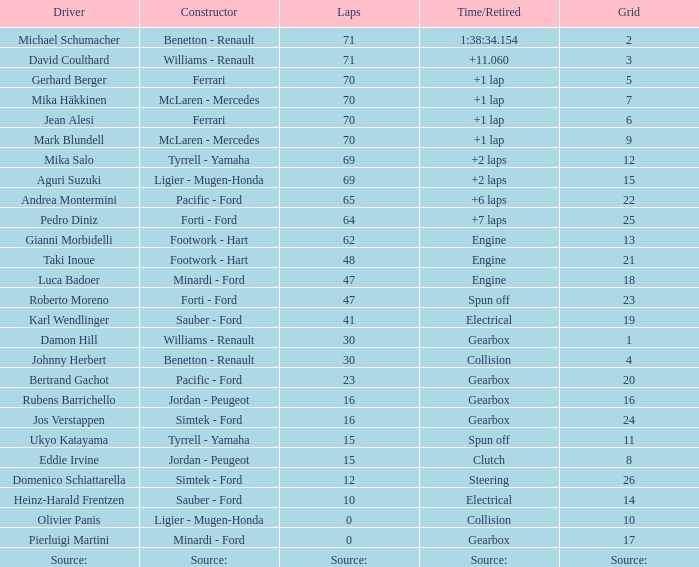Which grid featured david coulthard as the driver? 3.0. 